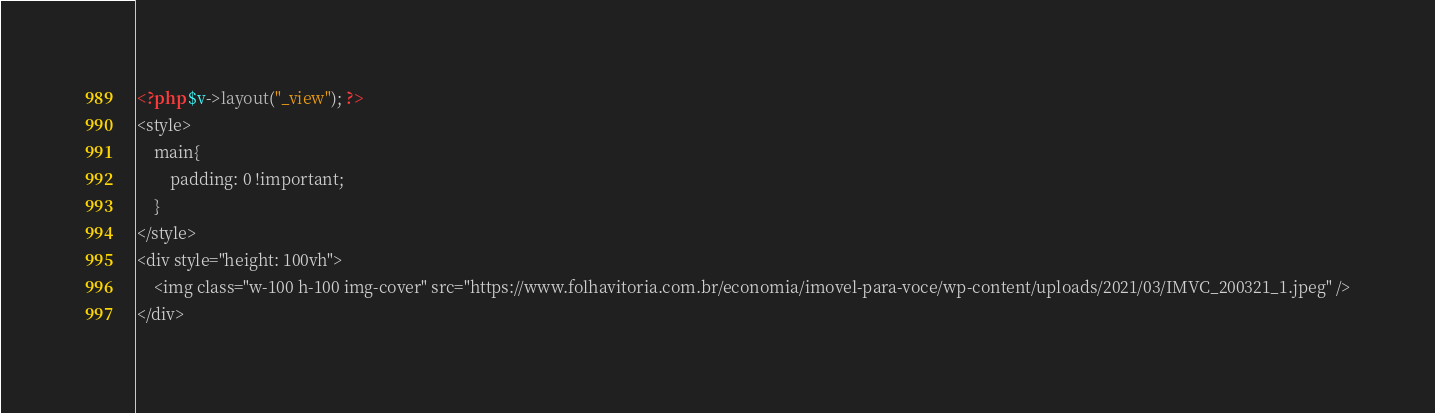<code> <loc_0><loc_0><loc_500><loc_500><_PHP_><?php $v->layout("_view"); ?>
<style>
    main{
        padding: 0 !important;
    }
</style>
<div style="height: 100vh">
    <img class="w-100 h-100 img-cover" src="https://www.folhavitoria.com.br/economia/imovel-para-voce/wp-content/uploads/2021/03/IMVC_200321_1.jpeg" />
</div>

</code> 